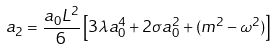<formula> <loc_0><loc_0><loc_500><loc_500>a _ { 2 } = \frac { a _ { 0 } L ^ { 2 } } { 6 } \left [ 3 \lambda a _ { 0 } ^ { 4 } + 2 \sigma a _ { 0 } ^ { 2 } + ( m ^ { 2 } - \omega ^ { 2 } ) \right ]</formula> 